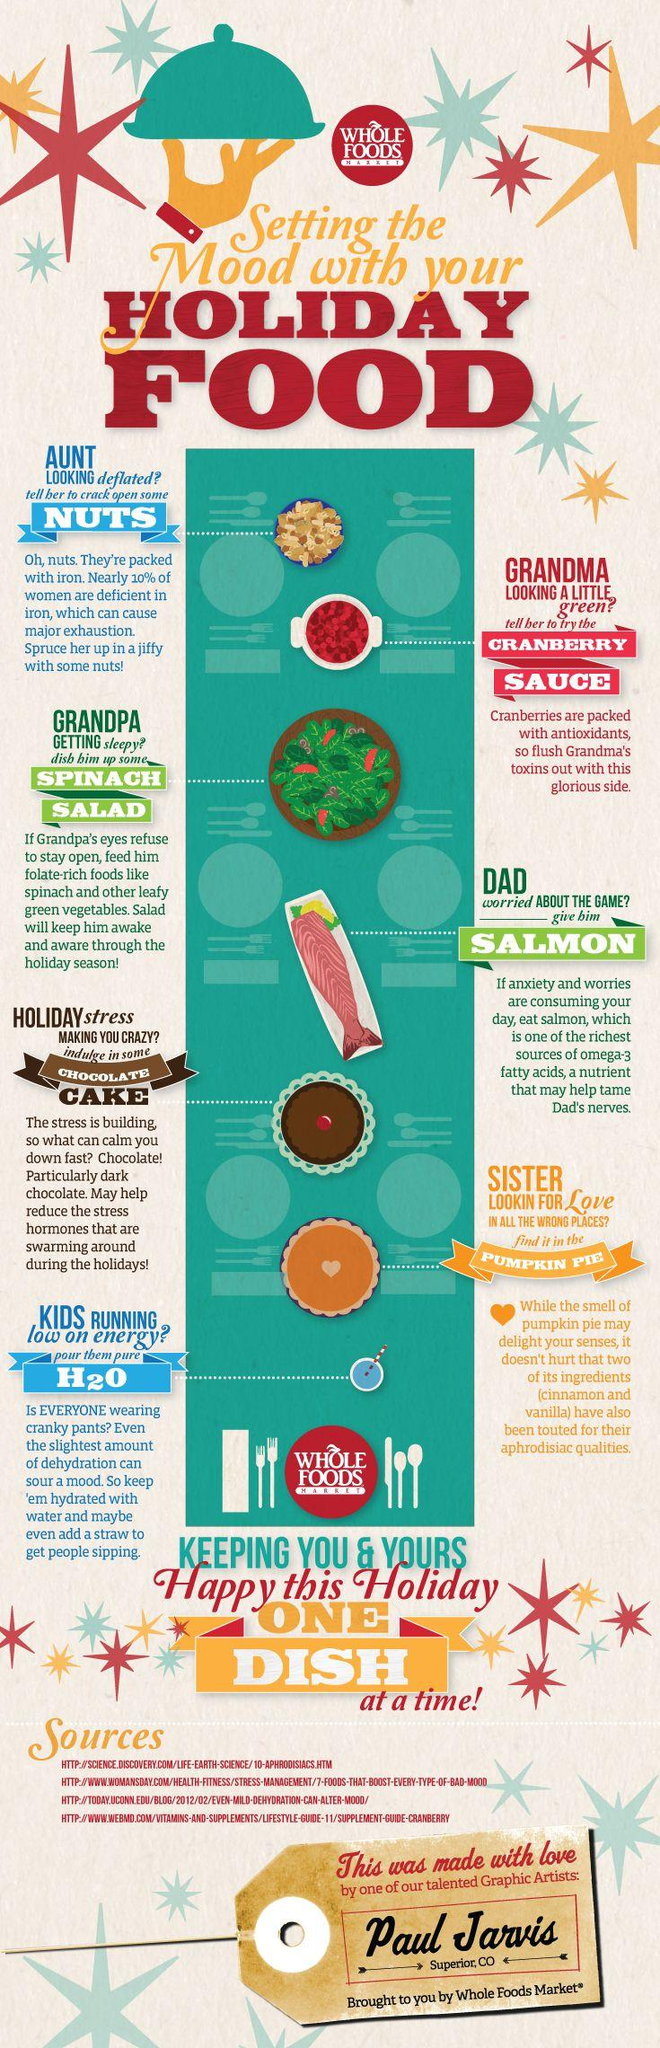Draw attention to some important aspects in this diagram. The dishes denoted by the green color are the Spinach Salad and the Salmon. The dish that can be served for sisters is pumpkin pie. There are two holiday foods that are listed in blue color. The cranberry sauce should be served to Grandma, as she is the appropriate recipient. 